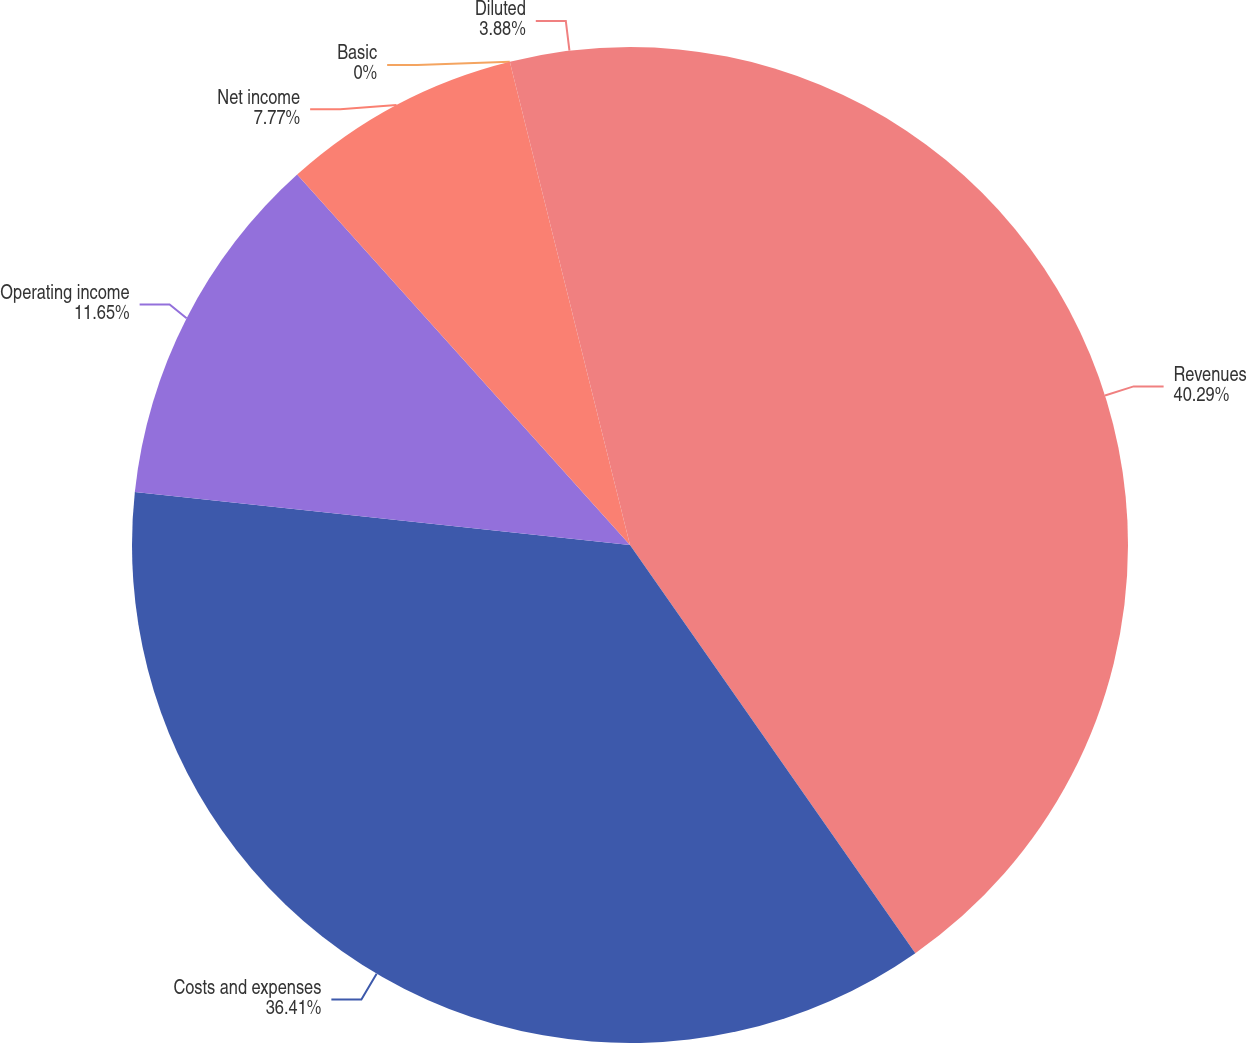Convert chart. <chart><loc_0><loc_0><loc_500><loc_500><pie_chart><fcel>Revenues<fcel>Costs and expenses<fcel>Operating income<fcel>Net income<fcel>Basic<fcel>Diluted<nl><fcel>40.29%<fcel>36.41%<fcel>11.65%<fcel>7.77%<fcel>0.0%<fcel>3.88%<nl></chart> 